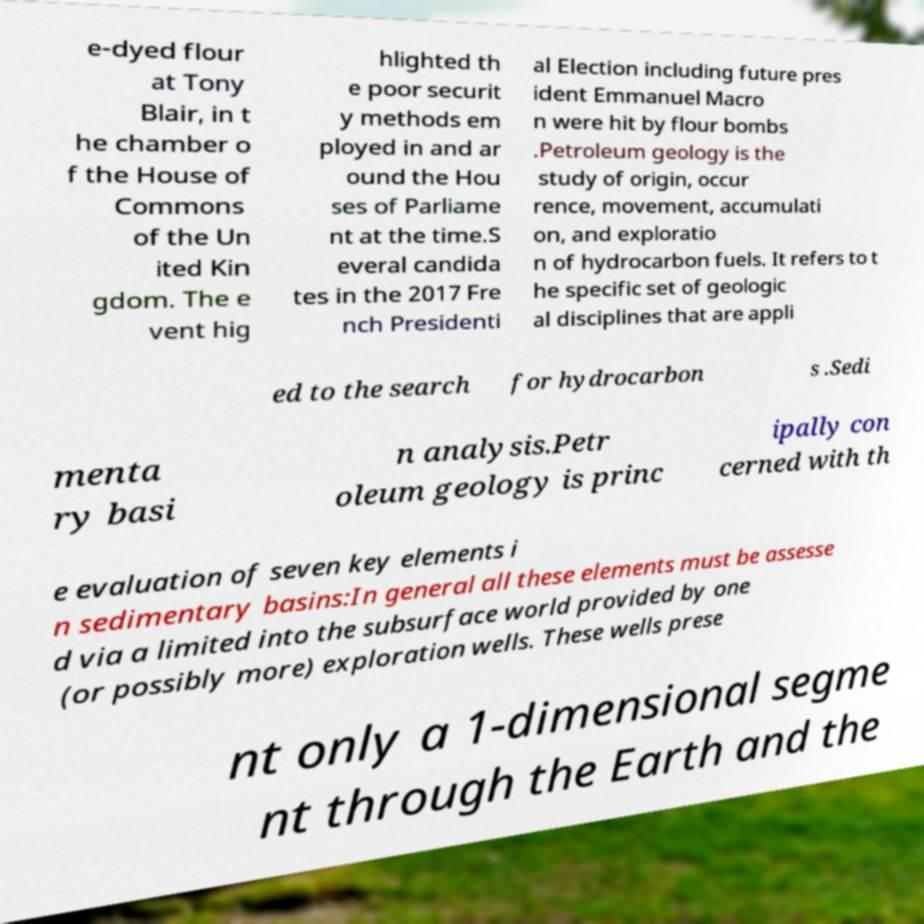For documentation purposes, I need the text within this image transcribed. Could you provide that? e-dyed flour at Tony Blair, in t he chamber o f the House of Commons of the Un ited Kin gdom. The e vent hig hlighted th e poor securit y methods em ployed in and ar ound the Hou ses of Parliame nt at the time.S everal candida tes in the 2017 Fre nch Presidenti al Election including future pres ident Emmanuel Macro n were hit by flour bombs .Petroleum geology is the study of origin, occur rence, movement, accumulati on, and exploratio n of hydrocarbon fuels. It refers to t he specific set of geologic al disciplines that are appli ed to the search for hydrocarbon s .Sedi menta ry basi n analysis.Petr oleum geology is princ ipally con cerned with th e evaluation of seven key elements i n sedimentary basins:In general all these elements must be assesse d via a limited into the subsurface world provided by one (or possibly more) exploration wells. These wells prese nt only a 1-dimensional segme nt through the Earth and the 